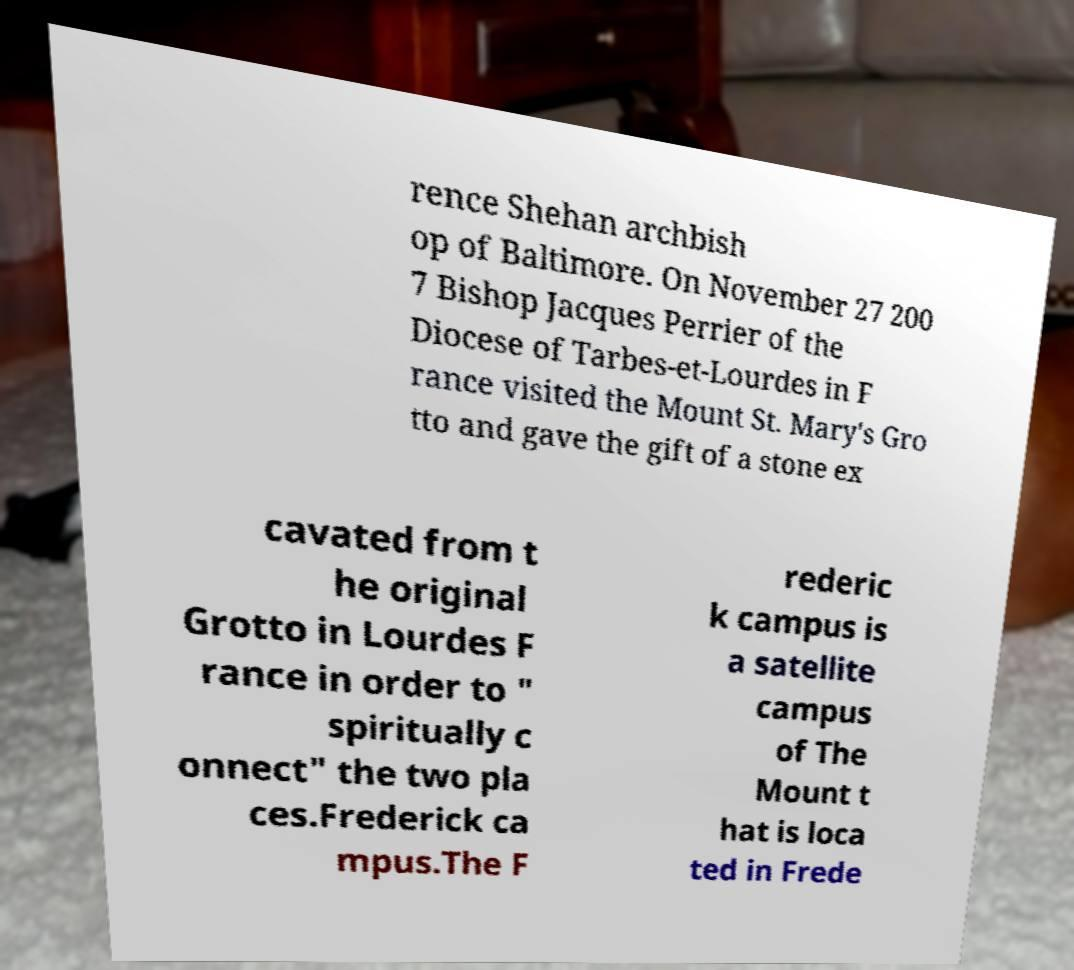Please read and relay the text visible in this image. What does it say? rence Shehan archbish op of Baltimore. On November 27 200 7 Bishop Jacques Perrier of the Diocese of Tarbes-et-Lourdes in F rance visited the Mount St. Mary's Gro tto and gave the gift of a stone ex cavated from t he original Grotto in Lourdes F rance in order to " spiritually c onnect" the two pla ces.Frederick ca mpus.The F rederic k campus is a satellite campus of The Mount t hat is loca ted in Frede 